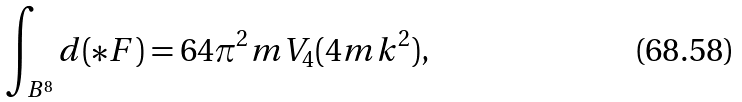<formula> <loc_0><loc_0><loc_500><loc_500>\int _ { B ^ { 8 } } d ( \ast F ) = 6 4 \pi ^ { 2 } m V _ { 4 } ( 4 m k ^ { 2 } ) ,</formula> 